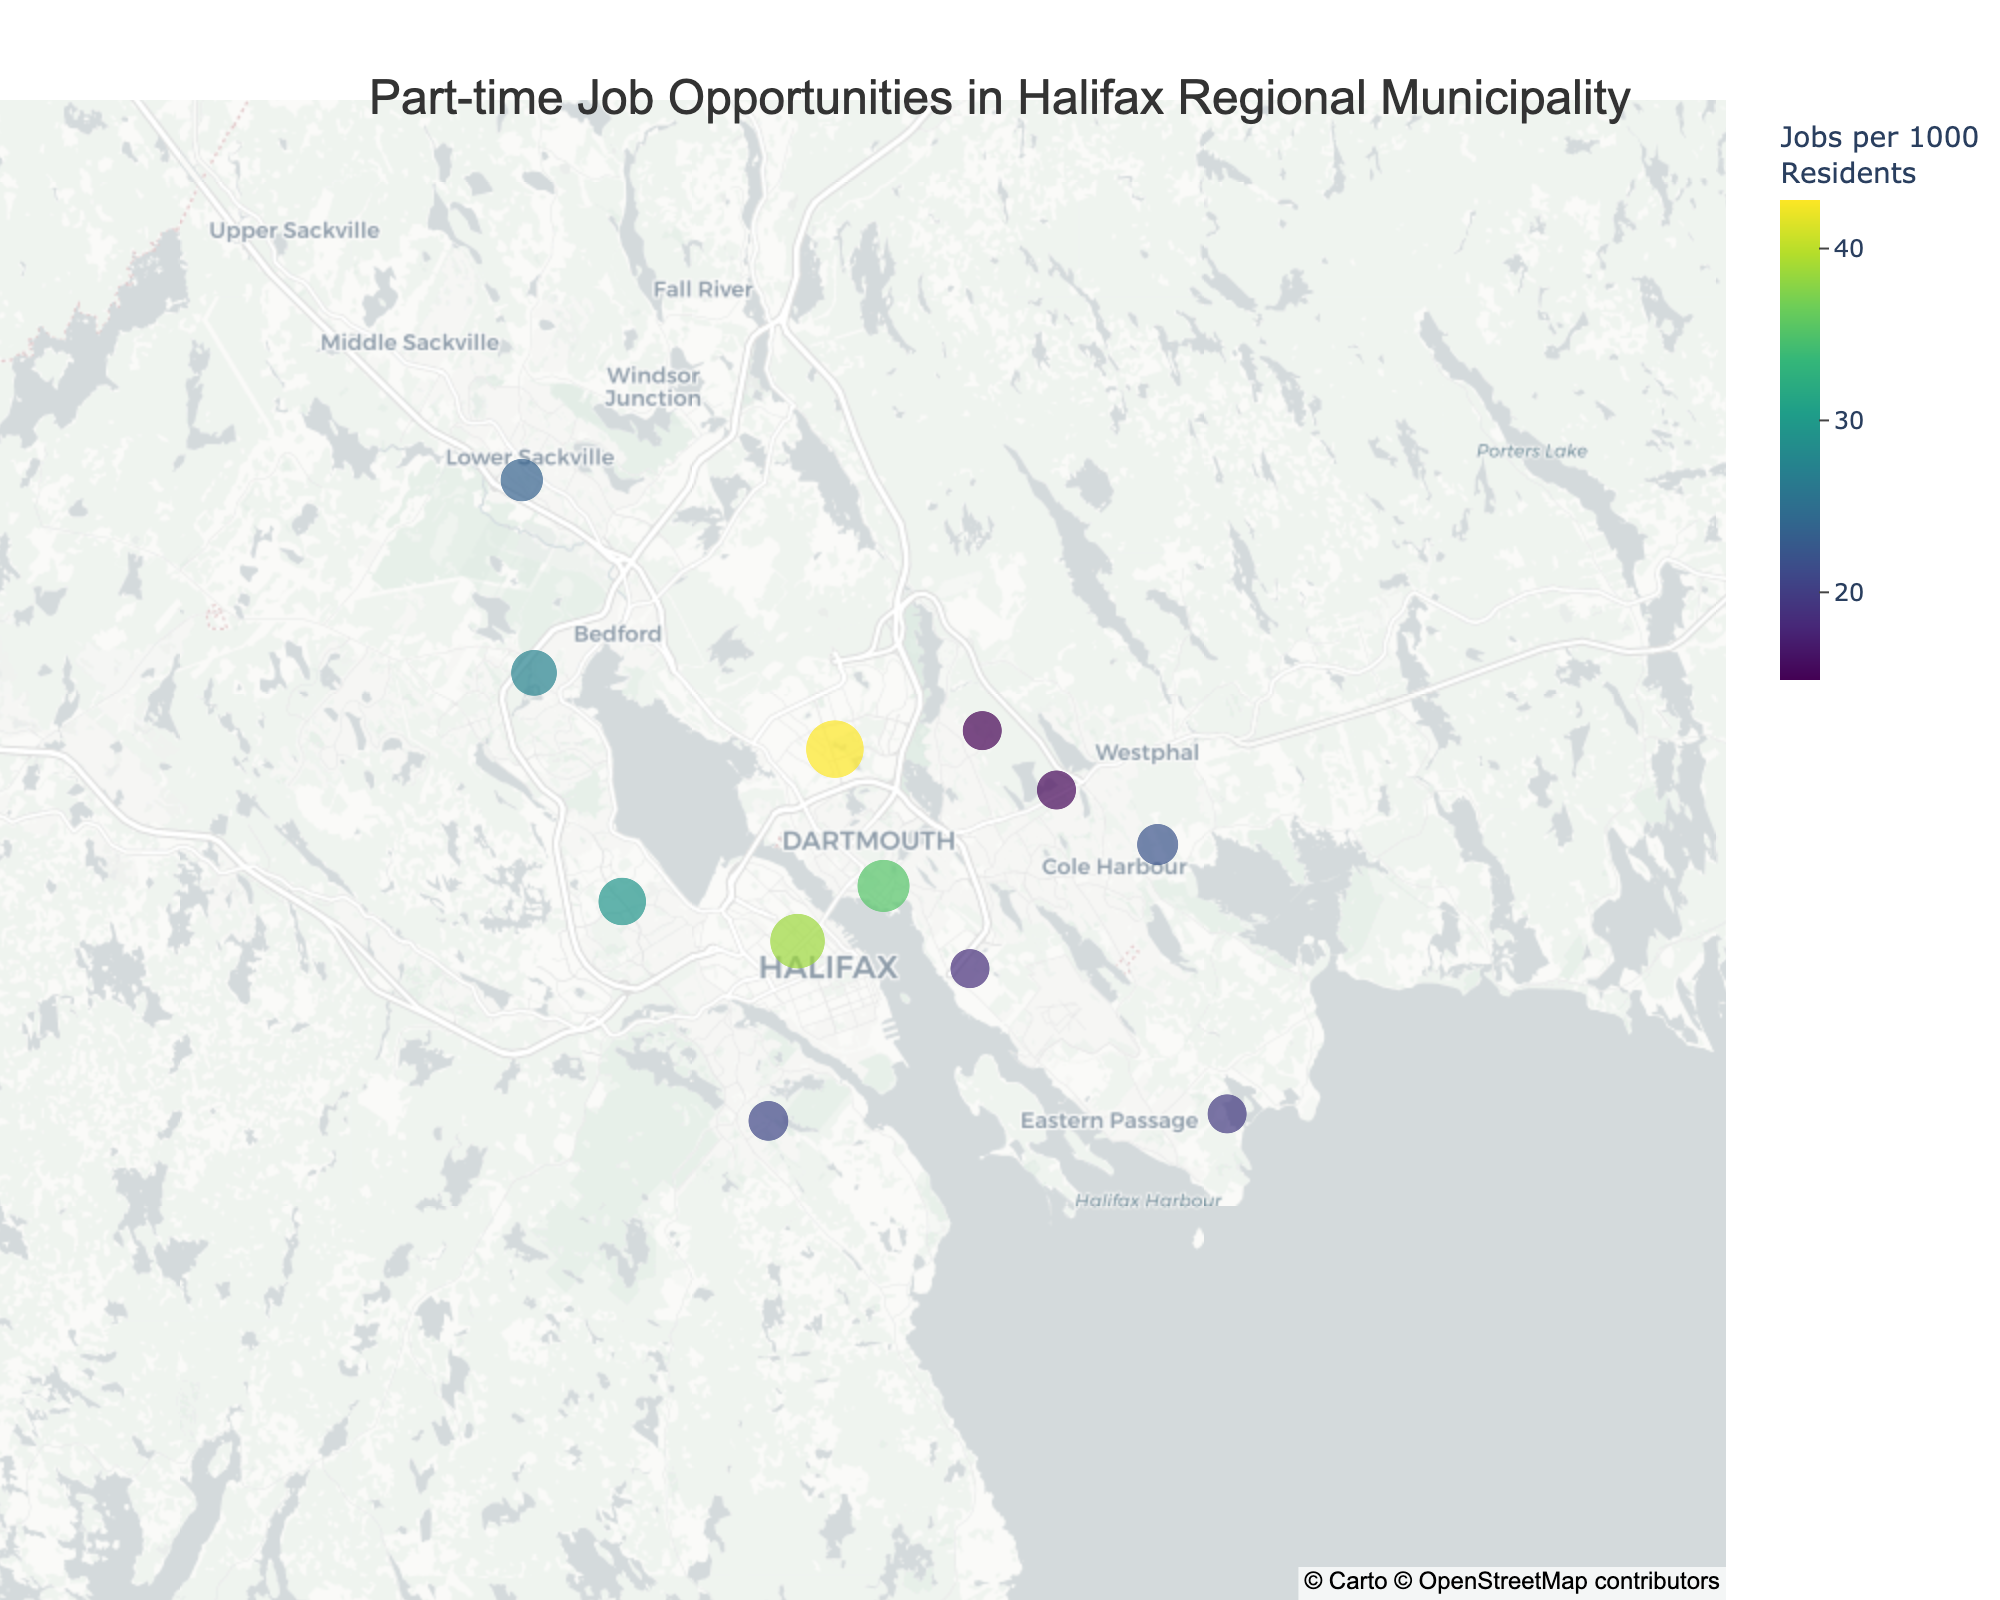What's the neighborhood with the highest density of part-time job opportunities? Look for the neighborhood with the largest circle and highest color intensity. This is Burnside.
Answer: Burnside Which neighborhood has the lowest density of part-time job opportunities? Identify the smallest circle with the least color intensity. This is Westphal.
Answer: Westphal How does the density of part-time job opportunities in Downtown Dartmouth compare to North End Halifax? Compare the circles and colors for both neighborhoods. Downtown Dartmouth (35.2) has a slightly lower density than North End Halifax (38.6).
Answer: North End Halifax has a slightly higher density What's the average density of part-time job opportunities in Portland Hills, Eastern Passage, and Sackville? Add the densities of these three neighborhoods and divide by 3: (15.3 + 19.7 + 23.5)/3 = 58.5/3 = 19.5
Answer: 19.5 Which two neighborhoods have the closest densities of part-time job opportunities? Find two neighborhoods with nearly equal circle sizes and color intensity. Westphal (14.9) and Portland Hills (15.3) are quite close.
Answer: Westphal and Portland Hills What is the range of part-time job densities across all neighborhoods? Subtract the smallest density value from the largest. Max is Burnside (42.8) and Min is Westphal (14.9). 42.8 - 14.9 = 27.9
Answer: 27.9 Are there more part-time job opportunities in neighborhoods closer to downtown Halifax? Compare the densities of neighborhoods like Downtown Dartmouth, North End Halifax, and Clayton Park against others further away. Generally, the closer ones have higher densities.
Answer: Yes, generally higher closer to downtown If a new university student had to choose between Bedford and Cole Harbour based on part-time job opportunities, which should they choose? Compare the densities: Bedford (27.3) has a higher density than Cole Harbour (22.1).
Answer: Bedford Which neighborhood south of Dartmouth has the highest density of part-time jobs? Identify neighborhoods such as Woodside and Eastern Passage. Woodside has a density of 18.6, and Eastern Passage has 19.7.
Answer: Eastern Passage What is the total density of part-time job opportunities for neighborhoods starting with 'B'? Add densities for Burnside, Bedford, and any other neighborhoods starting with 'B'. (42.8 + 27.3) = 70.1
Answer: 70.1 